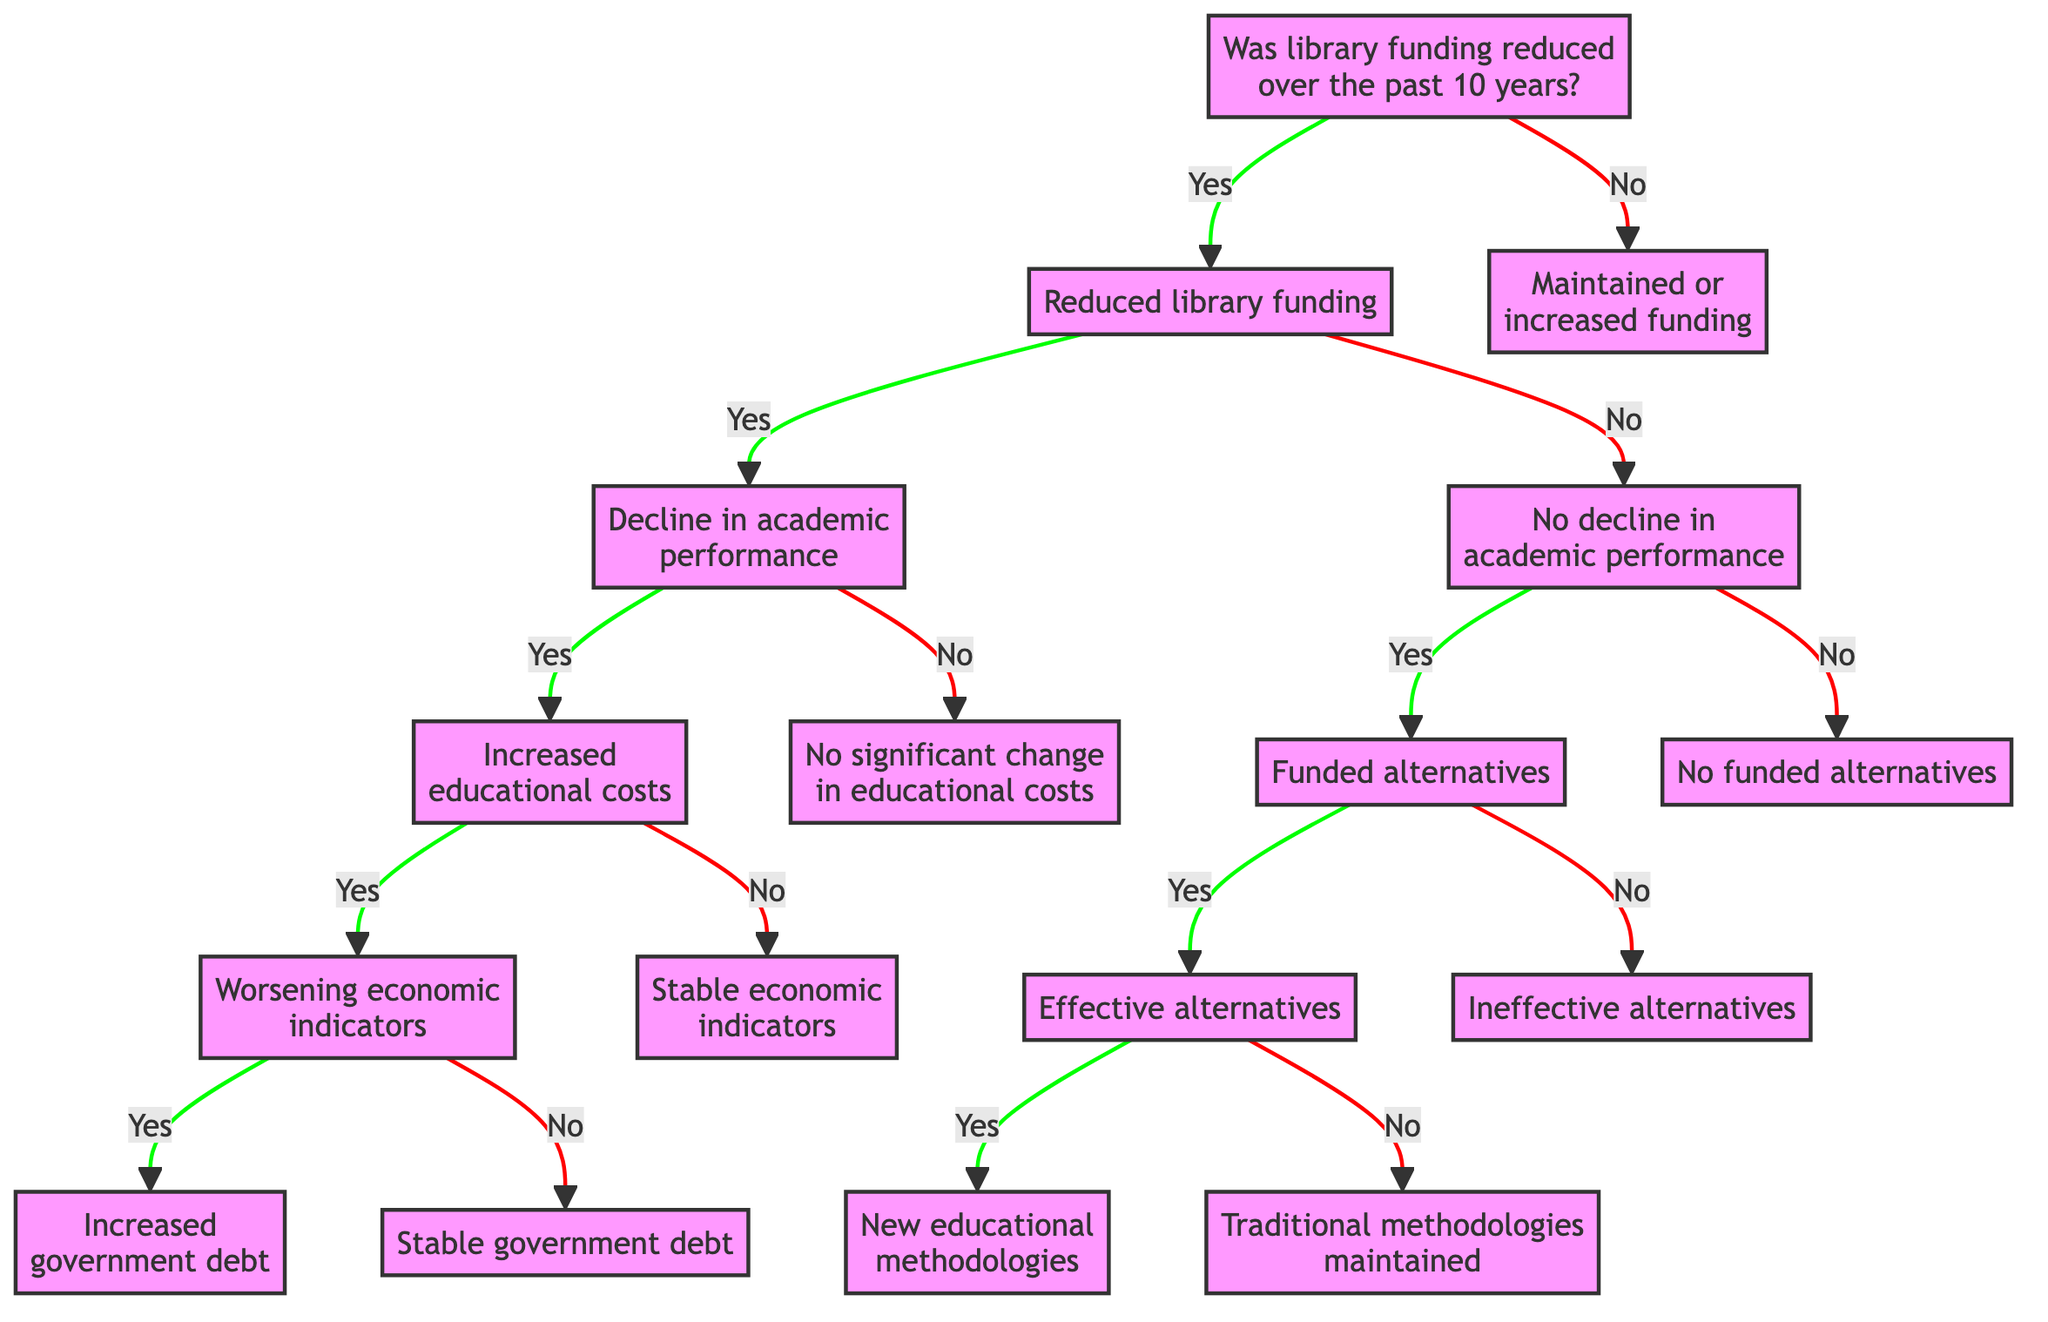Was library funding reduced over the past 10 years? This is the starting question at the root of the decision tree. The node presents the initial decision point, leading to either "Reduced library funding" for a "Yes" answer or "Maintained or increased funding" for a "No" answer.
Answer: Yes What happens if there is no decline in academic performance? According to the tree, if there is no decline in academic performance, the next question pertains to whether alternative educational resources were funded. This output branches to either "Funded alternatives" for a "Yes" answer or "No funded alternatives" for a "No" answer.
Answer: Funded alternatives How many outcomes are associated with reduced library funding? From the "Reduced library funding" node, there are two main branches: one leading to a "Decline in academic performance" and the other to "No decline in academic performance." Subsequently, these also branch out, indicating a total of four outcomes for the scenarios stemming from reduced funding.
Answer: Four What do worsening economic indicators lead to? If the decision path goes through "Increased educational costs" with subsequent "Yes" to "Did economic indicators (like employment rates) worsen?", the next question leads to whether government debt increased. This indicates a direct consequence of worsening indicators resulting in "Increased government debt".
Answer: Increased government debt What is the impact of effective alternatives? If the alternatives to libraries were effective, this leads to a follow-up question regarding whether innovation led to new educational methodologies. The presence of innovation signifies a positive outcome stemming from effective alternatives.
Answer: New educational methodologies Did maintained funding lead to traditional methodologies being maintained? Following a "No" from the "Were alternative educational resources funded?" question, the flow directs us to the conclusion that traditional methodologies were maintained, highlighting the lack of progress or innovation in educational approaches due to no alternatives being funded.
Answer: Traditional methodologies maintained 